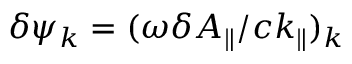Convert formula to latex. <formula><loc_0><loc_0><loc_500><loc_500>\delta \psi _ { k } = ( \omega \delta A _ { \| } / c k _ { \| } ) _ { k }</formula> 